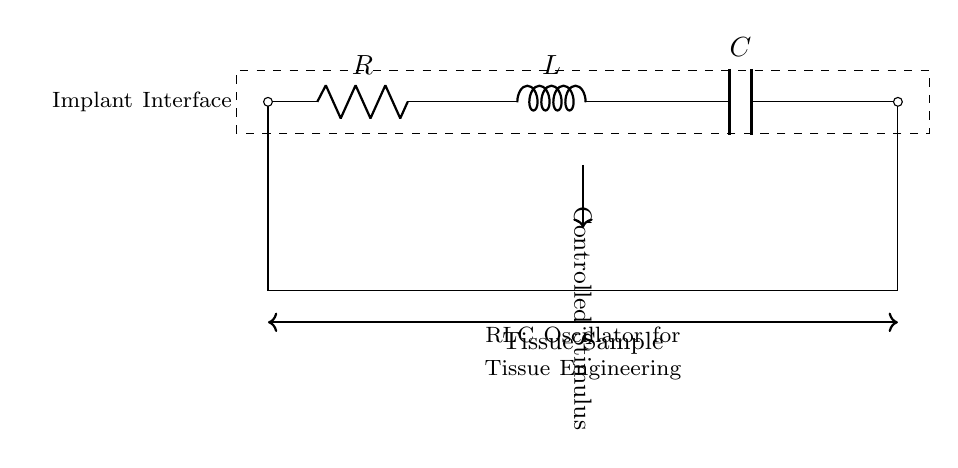What are the components in this circuit? The circuit consists of three main components: a resistor, an inductor, and a capacitor. These are labeled in the circuit diagram.
Answer: resistor, inductor, capacitor What is the primary function of this RLC oscillator? The RLC oscillator is designed to generate controlled electrical stimuli for tissue engineering experiments, shown by the label indicating "Controlled Stimulus."
Answer: controlled electrical stimuli What is the orientation of the circuit connections? The circuit components are connected in series, meaning that they are arranged sequentially one after the other from the input to the output.
Answer: series What role does the capacitor play in this RLC oscillator? The capacitor stores and releases electrical energy, contributing to the oscillation behavior of the circuit, which is essential for creating controlled stimuli.
Answer: energy storage How does the presence of the inductor affect the frequency of oscillation? The inductor stores energy in a magnetic field when current passes through it, and combined with the resistor and capacitor, it influences the natural frequency of the oscillation based on the RLC formula.
Answer: influences frequency What is indicated by the dashed rectangle in the diagram? The dashed rectangle outlines the entire RLC oscillator circuit, typically indicating the main boundary of the circuit in question, illustrating where the electrical functions occur.
Answer: circuit boundary How is the tissue sample integrated into the circuit design? The tissue sample is connected externally across the circuit (indicated by the double arrows), suggesting that the controlled stimuli will be applied directly to it during experiments.
Answer: externally connected 